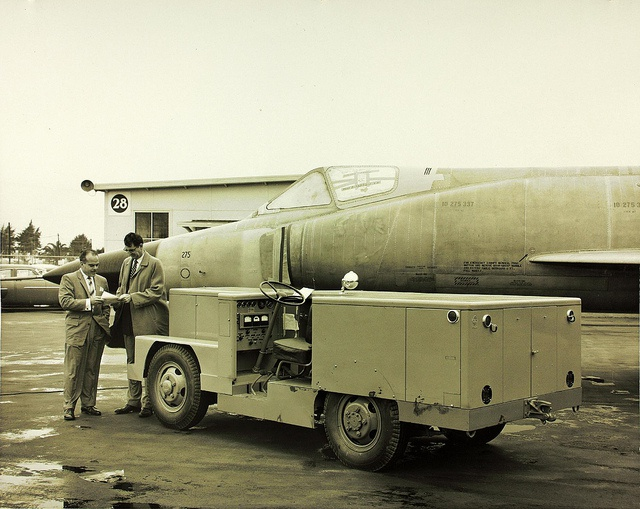Describe the objects in this image and their specific colors. I can see truck in beige, olive, and black tones, airplane in beige, tan, and black tones, people in beige, black, olive, darkgreen, and gray tones, people in beige, black, tan, darkgreen, and gray tones, and car in beige, black, darkgreen, and tan tones in this image. 